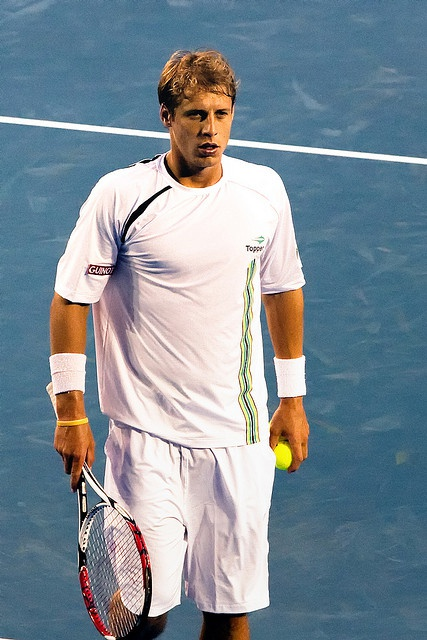Describe the objects in this image and their specific colors. I can see people in gray, white, darkgray, pink, and brown tones, tennis racket in gray, lightgray, black, and darkgray tones, and sports ball in gray, yellow, and olive tones in this image. 